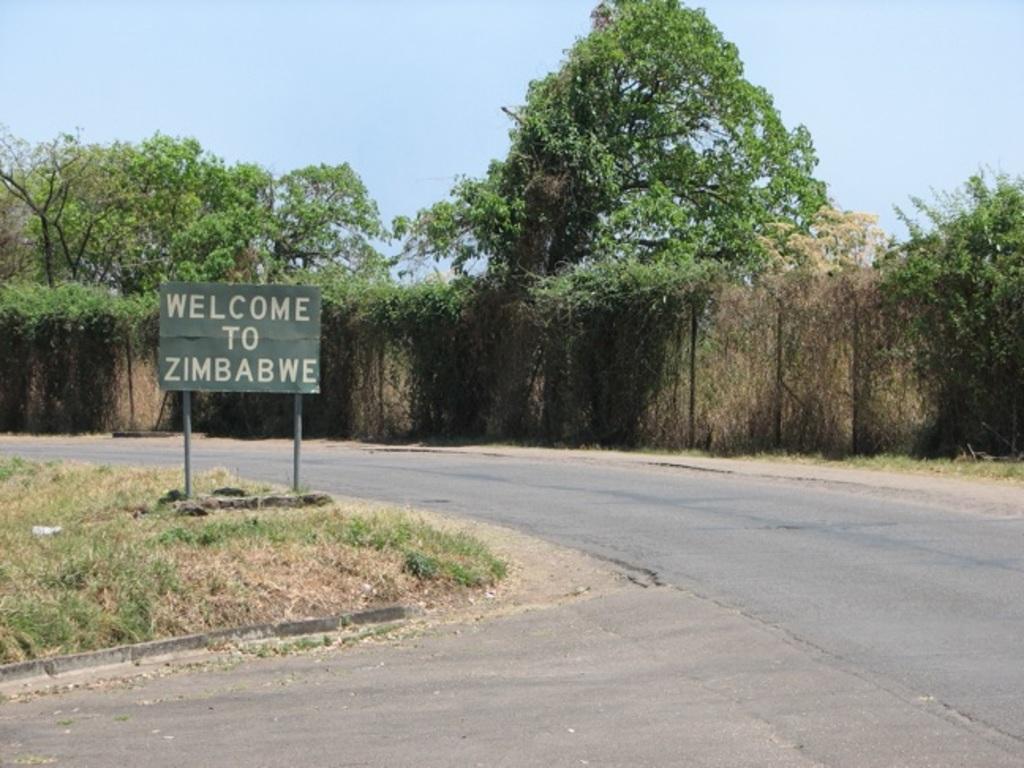Could you give a brief overview of what you see in this image? In this picture we can see some text on a board. There is some grass on the ground. We can see a road. There are a few plants and trees in the background. 